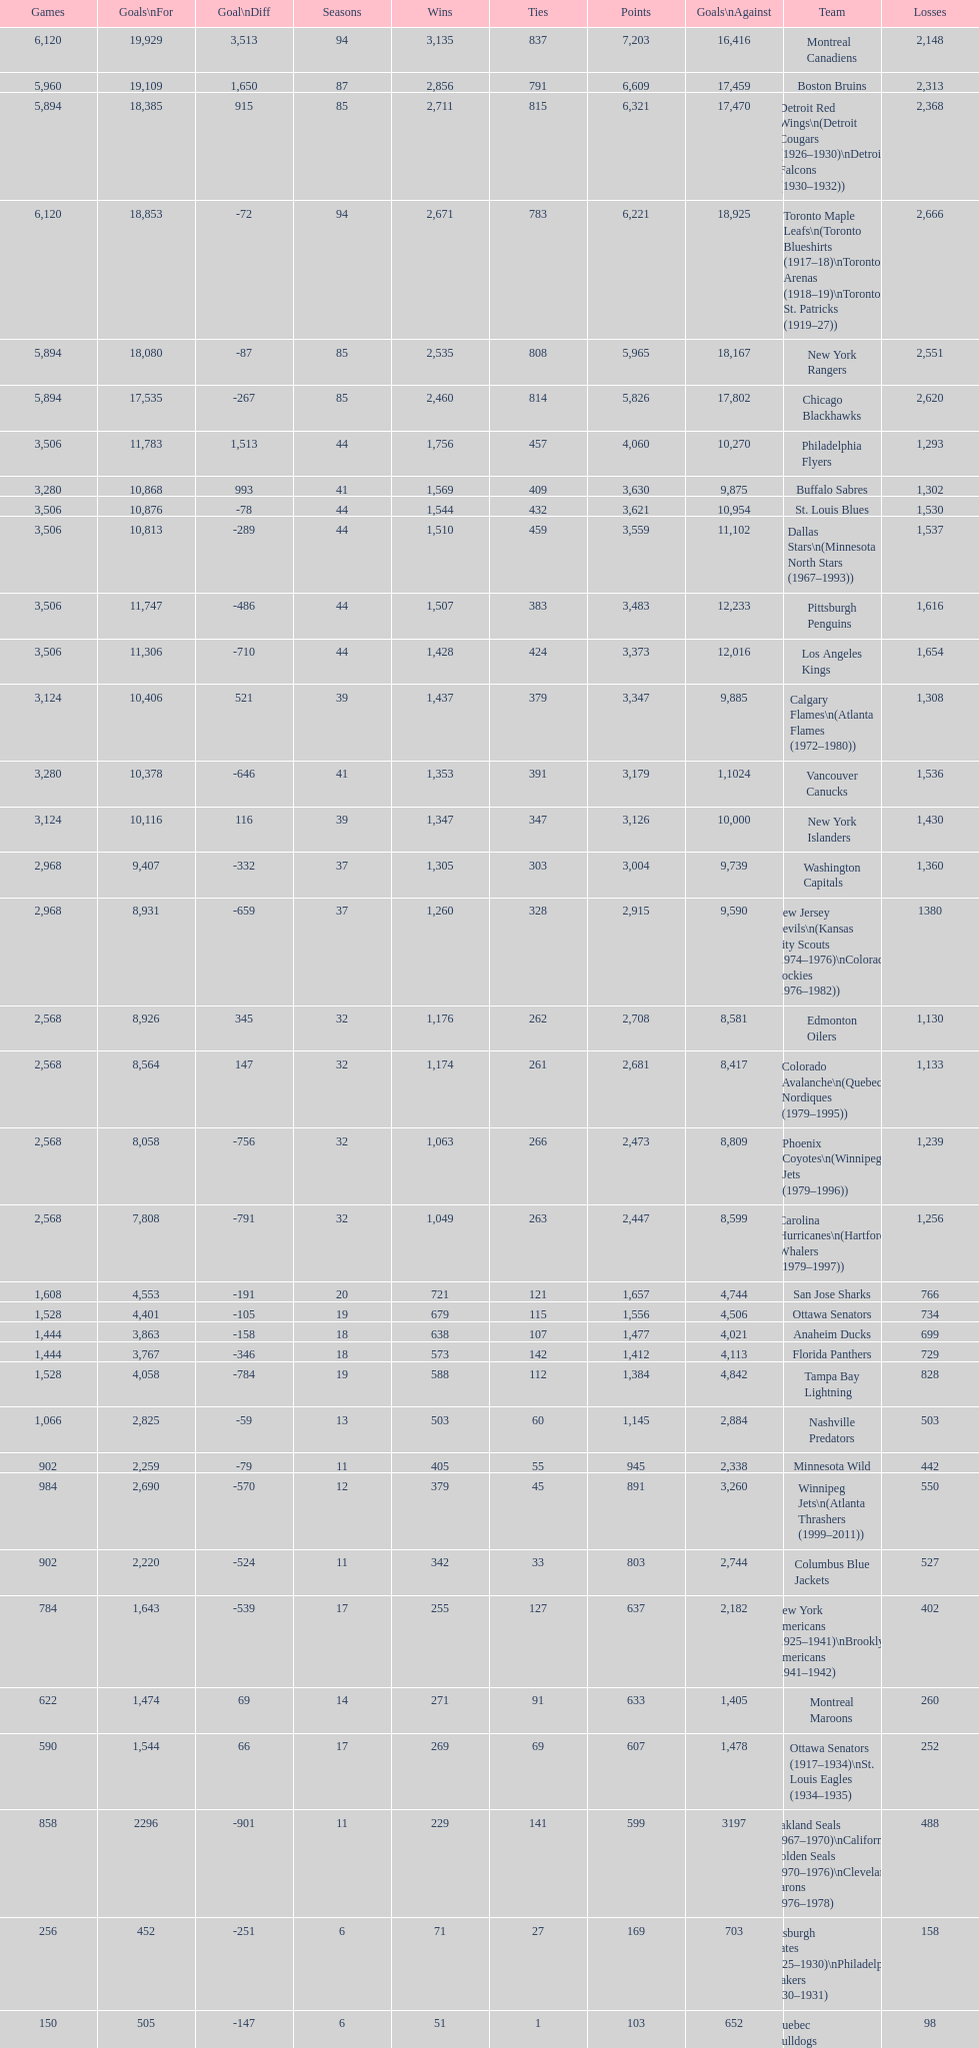Who is at the top of the list? Montreal Canadiens. 